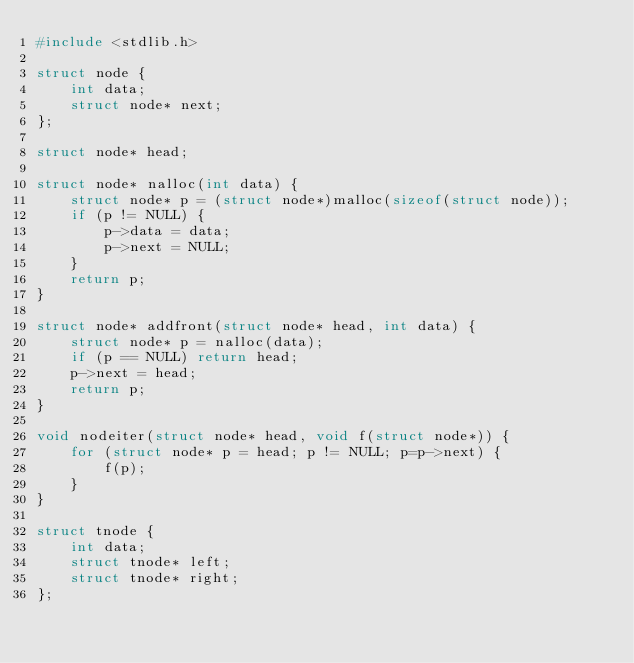Convert code to text. <code><loc_0><loc_0><loc_500><loc_500><_C_>#include <stdlib.h>

struct node {
    int data;
    struct node* next;
};

struct node* head;

struct node* nalloc(int data) {
    struct node* p = (struct node*)malloc(sizeof(struct node));
    if (p != NULL) {
        p->data = data;
        p->next = NULL;
    }
    return p;
}

struct node* addfront(struct node* head, int data) {
    struct node* p = nalloc(data);
    if (p == NULL) return head;
    p->next = head;
    return p;
}

void nodeiter(struct node* head, void f(struct node*)) {
    for (struct node* p = head; p != NULL; p=p->next) {
        f(p);
    }
}

struct tnode {
    int data;
    struct tnode* left;
    struct tnode* right;
};
</code> 